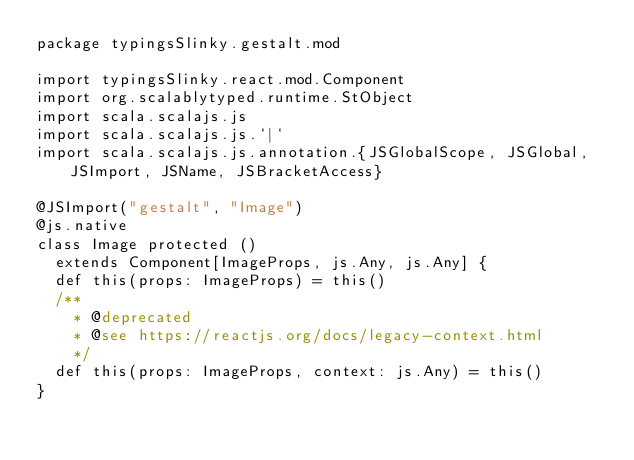Convert code to text. <code><loc_0><loc_0><loc_500><loc_500><_Scala_>package typingsSlinky.gestalt.mod

import typingsSlinky.react.mod.Component
import org.scalablytyped.runtime.StObject
import scala.scalajs.js
import scala.scalajs.js.`|`
import scala.scalajs.js.annotation.{JSGlobalScope, JSGlobal, JSImport, JSName, JSBracketAccess}

@JSImport("gestalt", "Image")
@js.native
class Image protected ()
  extends Component[ImageProps, js.Any, js.Any] {
  def this(props: ImageProps) = this()
  /**
    * @deprecated
    * @see https://reactjs.org/docs/legacy-context.html
    */
  def this(props: ImageProps, context: js.Any) = this()
}
</code> 